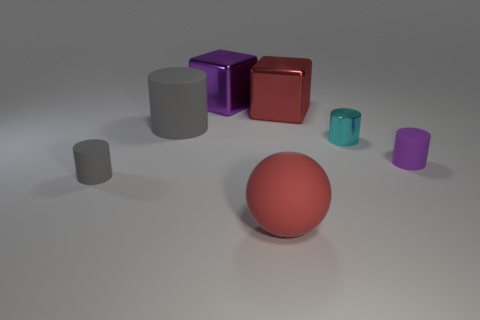Subtract all metal cylinders. How many cylinders are left? 3 Subtract all purple cubes. How many cubes are left? 1 Subtract all gray cubes. How many gray cylinders are left? 2 Add 1 large purple things. How many objects exist? 8 Subtract all blocks. How many objects are left? 5 Subtract 1 cubes. How many cubes are left? 1 Add 2 big cubes. How many big cubes exist? 4 Subtract 0 green blocks. How many objects are left? 7 Subtract all blue cylinders. Subtract all green balls. How many cylinders are left? 4 Subtract all large balls. Subtract all big red rubber things. How many objects are left? 5 